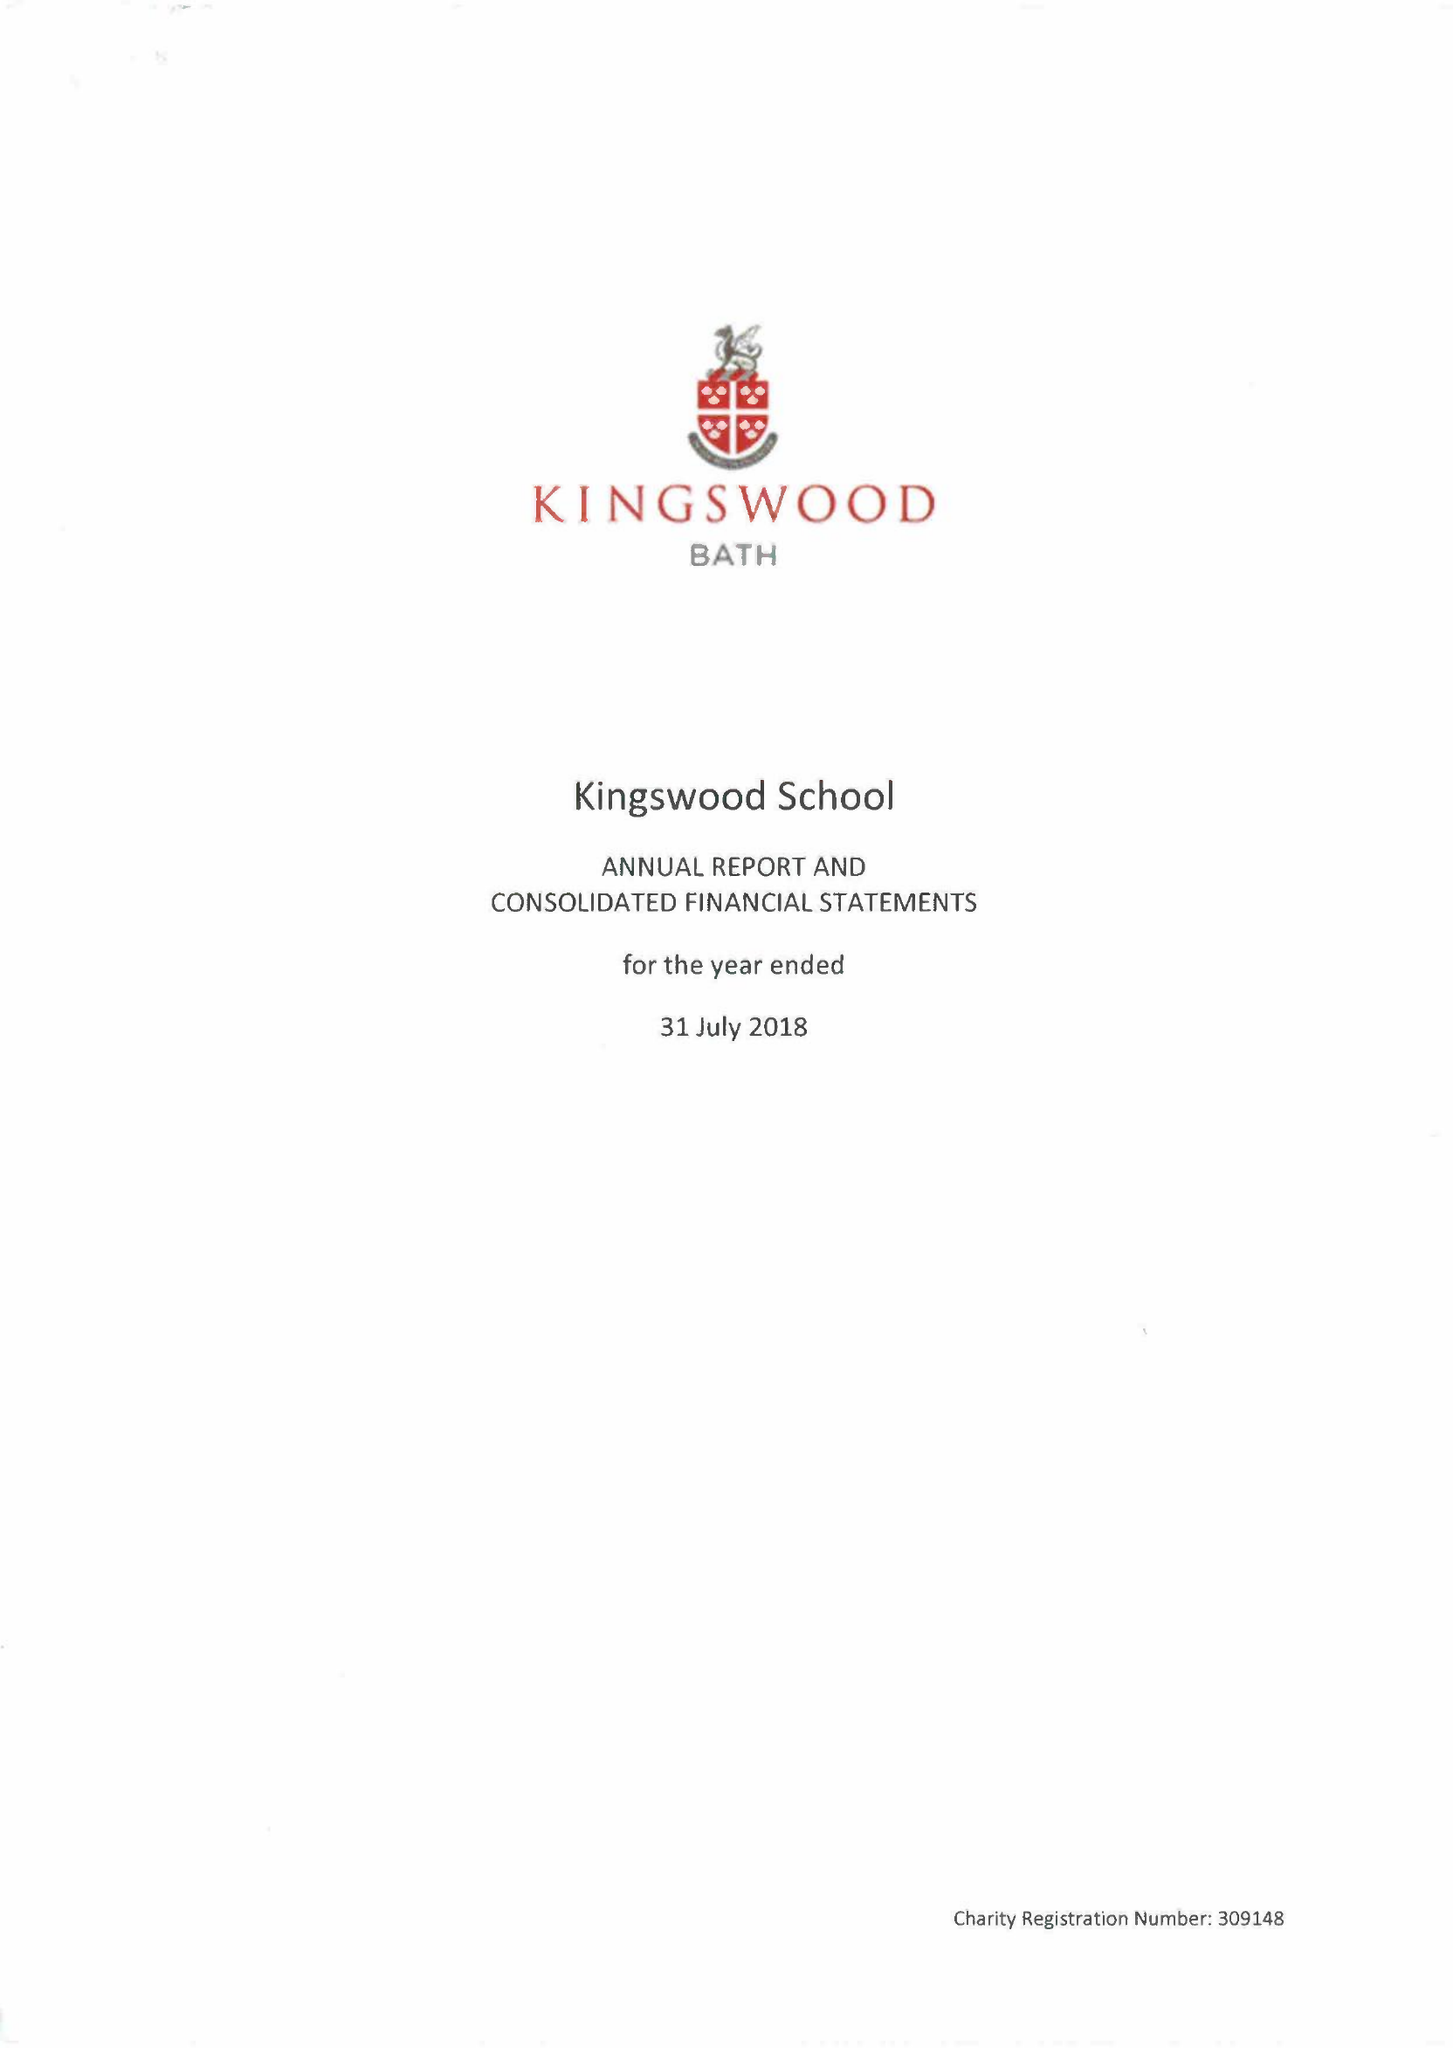What is the value for the income_annually_in_british_pounds?
Answer the question using a single word or phrase. 18346039.00 